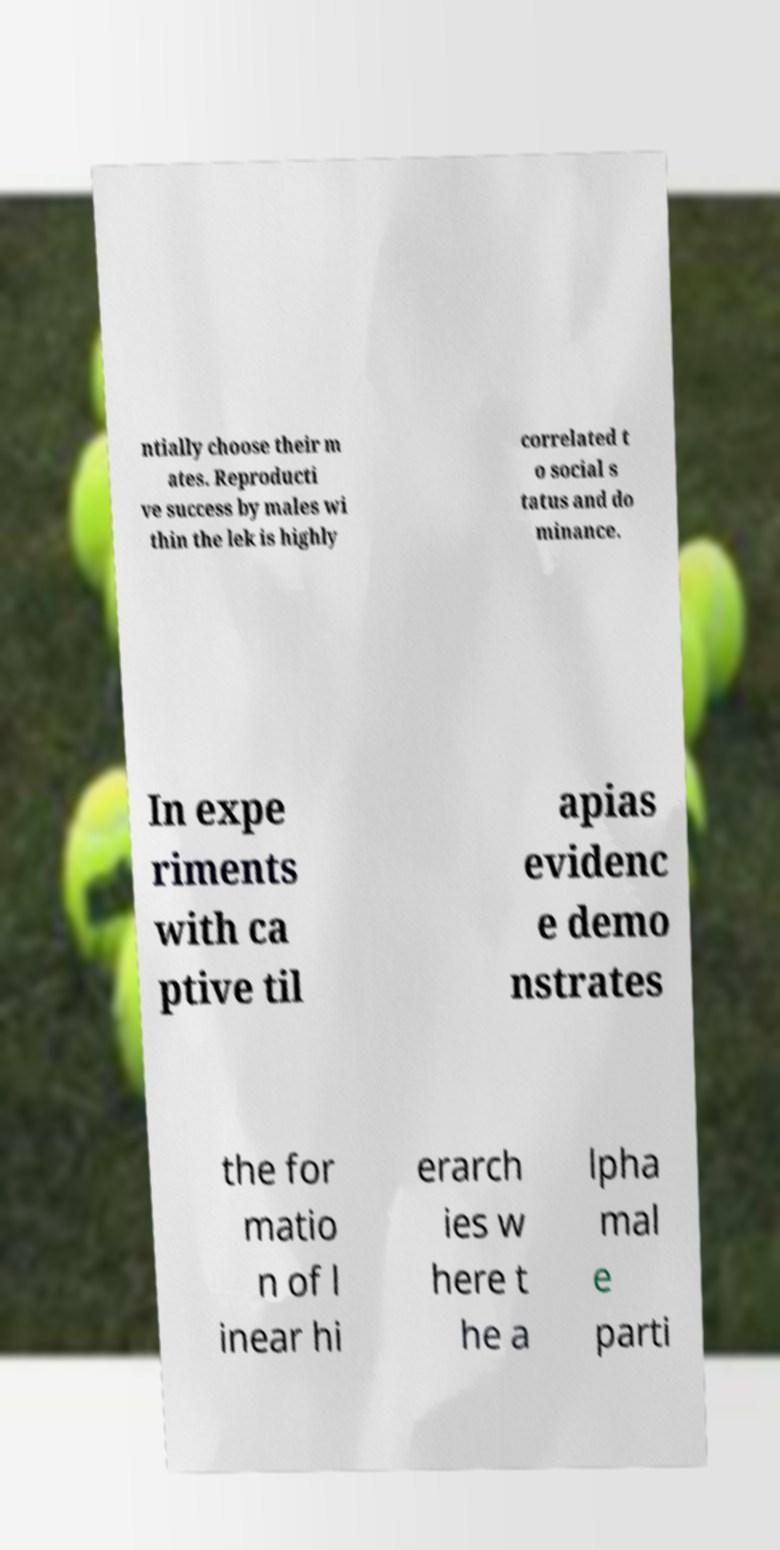I need the written content from this picture converted into text. Can you do that? ntially choose their m ates. Reproducti ve success by males wi thin the lek is highly correlated t o social s tatus and do minance. In expe riments with ca ptive til apias evidenc e demo nstrates the for matio n of l inear hi erarch ies w here t he a lpha mal e parti 